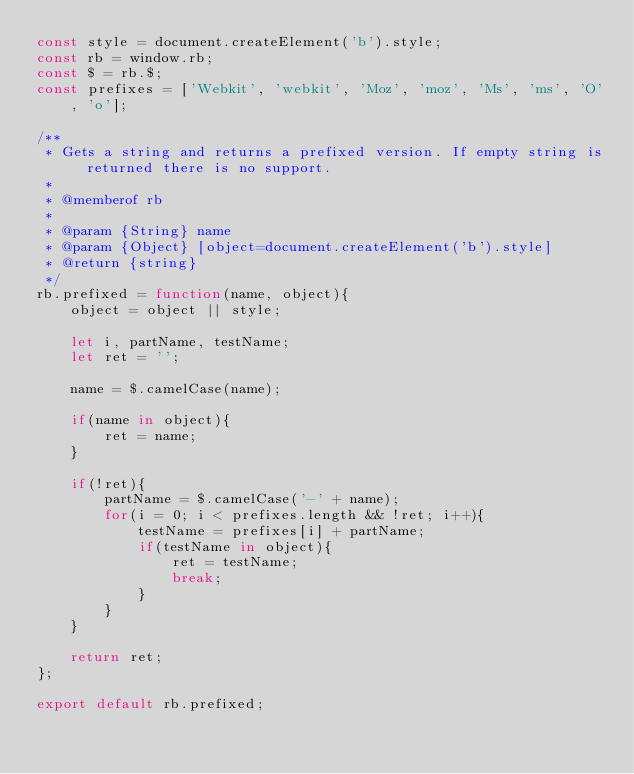<code> <loc_0><loc_0><loc_500><loc_500><_JavaScript_>const style = document.createElement('b').style;
const rb = window.rb;
const $ = rb.$;
const prefixes = ['Webkit', 'webkit', 'Moz', 'moz', 'Ms', 'ms', 'O', 'o'];

/**
 * Gets a string and returns a prefixed version. If empty string is returned there is no support.
 *
 * @memberof rb
 *
 * @param {String} name
 * @param {Object} [object=document.createElement('b').style]
 * @return {string}
 */
rb.prefixed = function(name, object){
    object = object || style;

    let i, partName, testName;
    let ret = '';

    name = $.camelCase(name);

    if(name in object){
        ret = name;
    }

    if(!ret){
        partName = $.camelCase('-' + name);
        for(i = 0; i < prefixes.length && !ret; i++){
            testName = prefixes[i] + partName;
            if(testName in object){
                ret = testName;
                break;
            }
        }
    }

    return ret;
};

export default rb.prefixed;
</code> 